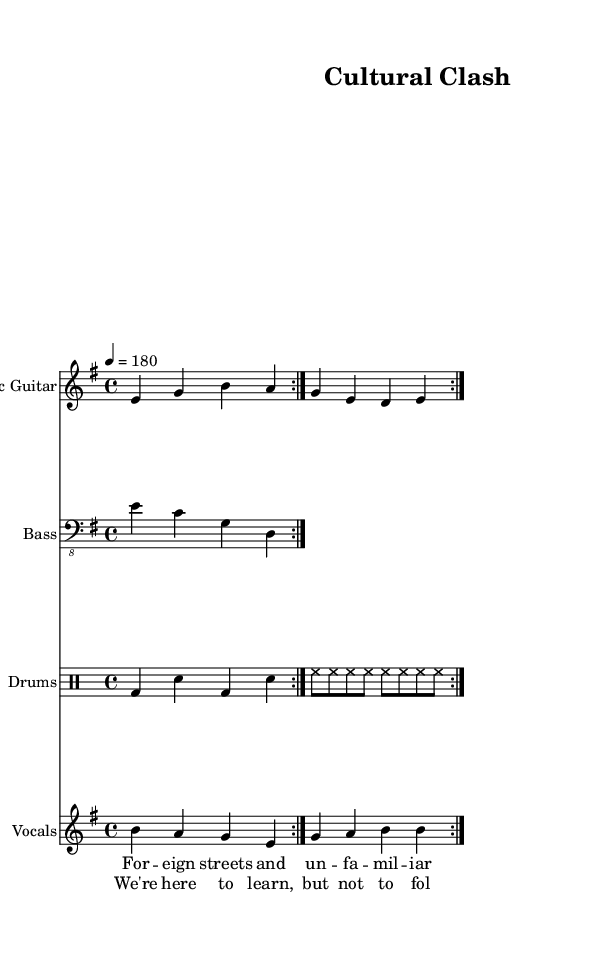What is the key signature of this music? The key signature is E minor, which includes one sharp (F#). You can identify this by looking at the key signature section in the sheet music, where the E minor key is indicated by a single sharp.
Answer: E minor What is the time signature of this music? The time signature is 4/4, which means there are four beats per measure and a quarter note represents one beat. This is clearly notated at the beginning of the score.
Answer: 4/4 What is the tempo marking for this piece? The tempo marking is 180 beats per minute. This is indicated by the tempo directive at the beginning of the music score, which specifies the speed of the piece.
Answer: 180 How many times is the first section of the electric guitar repeated? The electric guitar part states that the section is to be repeated two times, as indicated by the "repeat volta 2" notation at the beginning of the electric guitar line.
Answer: 2 What type of drum pattern is used in this score? The drum part consists of a basic rock rhythm, alternating between bass and snare drums. The notation shows repeated bass drum (bd) and snare (sn) hits, making it suitable for punk rock music.
Answer: Rock rhythm What do the lyrics of the chorus reflect about the song's theme? The chorus expresses a critical view of conforming to outdated social norms and emphasizes the desire to learn without following old ways. This is reflective of punk's anti-establishment ideology, which critiques conventional attitudes.
Answer: Anti-establishment How many instruments are featured in this score? There are four instruments featured in this score: electric guitar, bass, drums, and vocals. This can be identified by the separate staves assigned to each instrument in the score layout.
Answer: Four 